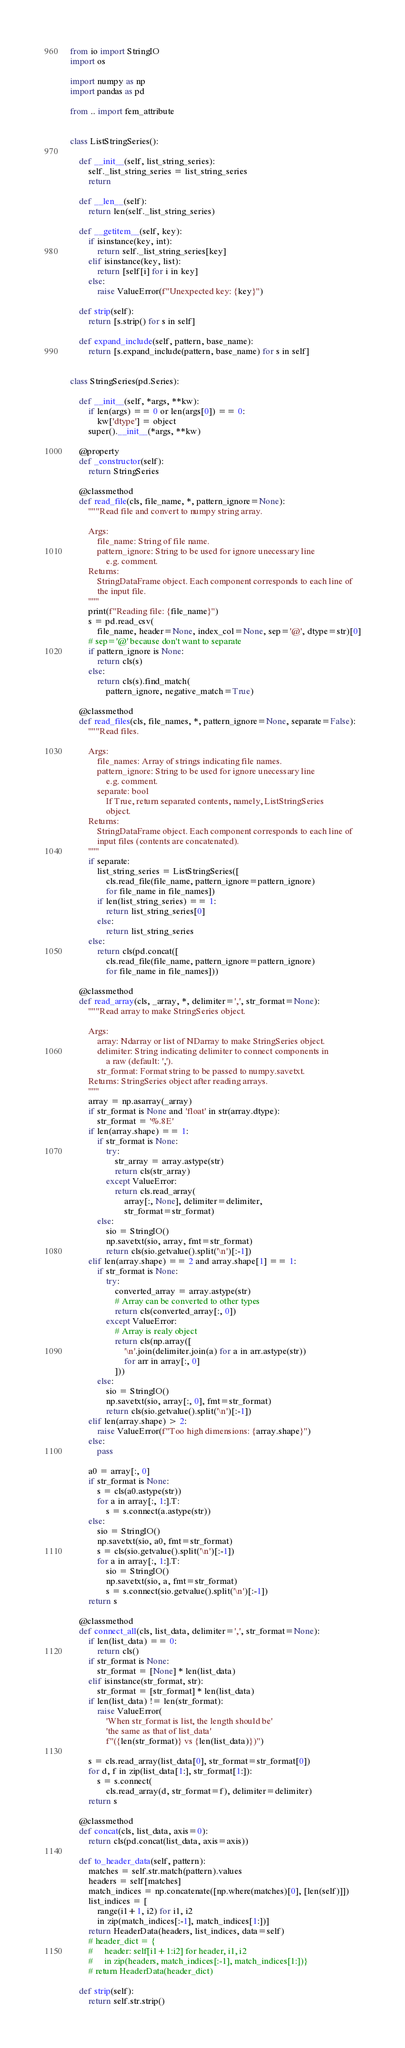<code> <loc_0><loc_0><loc_500><loc_500><_Python_>from io import StringIO
import os

import numpy as np
import pandas as pd

from .. import fem_attribute


class ListStringSeries():

    def __init__(self, list_string_series):
        self._list_string_series = list_string_series
        return

    def __len__(self):
        return len(self._list_string_series)

    def __getitem__(self, key):
        if isinstance(key, int):
            return self._list_string_series[key]
        elif isinstance(key, list):
            return [self[i] for i in key]
        else:
            raise ValueError(f"Unexpected key: {key}")

    def strip(self):
        return [s.strip() for s in self]

    def expand_include(self, pattern, base_name):
        return [s.expand_include(pattern, base_name) for s in self]


class StringSeries(pd.Series):

    def __init__(self, *args, **kw):
        if len(args) == 0 or len(args[0]) == 0:
            kw['dtype'] = object
        super().__init__(*args, **kw)

    @property
    def _constructor(self):
        return StringSeries

    @classmethod
    def read_file(cls, file_name, *, pattern_ignore=None):
        """Read file and convert to numpy string array.

        Args:
            file_name: String of file name.
            pattern_ignore: String to be used for ignore unecessary line
                e.g. comment.
        Returns:
            StringDataFrame object. Each component corresponds to each line of
            the input file.
        """
        print(f"Reading file: {file_name}")
        s = pd.read_csv(
            file_name, header=None, index_col=None, sep='@', dtype=str)[0]
        # sep='@' because don't want to separate
        if pattern_ignore is None:
            return cls(s)
        else:
            return cls(s).find_match(
                pattern_ignore, negative_match=True)

    @classmethod
    def read_files(cls, file_names, *, pattern_ignore=None, separate=False):
        """Read files.

        Args:
            file_names: Array of strings indicating file names.
            pattern_ignore: String to be used for ignore unecessary line
                e.g. comment.
            separate: bool
                If True, return separated contents, namely, ListStringSeries
                object.
        Returns:
            StringDataFrame object. Each component corresponds to each line of
            input files (contents are concatenated).
        """
        if separate:
            list_string_series = ListStringSeries([
                cls.read_file(file_name, pattern_ignore=pattern_ignore)
                for file_name in file_names])
            if len(list_string_series) == 1:
                return list_string_series[0]
            else:
                return list_string_series
        else:
            return cls(pd.concat([
                cls.read_file(file_name, pattern_ignore=pattern_ignore)
                for file_name in file_names]))

    @classmethod
    def read_array(cls, _array, *, delimiter=',', str_format=None):
        """Read array to make StringSeries object.

        Args:
            array: Ndarray or list of NDarray to make StringSeries object.
            delimiter: String indicating delimiter to connect components in
                a raw (default: ',').
            str_format: Format string to be passed to numpy.savetxt.
        Returns: StringSeries object after reading arrays.
        """
        array = np.asarray(_array)
        if str_format is None and 'float' in str(array.dtype):
            str_format = '%.8E'
        if len(array.shape) == 1:
            if str_format is None:
                try:
                    str_array = array.astype(str)
                    return cls(str_array)
                except ValueError:
                    return cls.read_array(
                        array[:, None], delimiter=delimiter,
                        str_format=str_format)
            else:
                sio = StringIO()
                np.savetxt(sio, array, fmt=str_format)
                return cls(sio.getvalue().split('\n')[:-1])
        elif len(array.shape) == 2 and array.shape[1] == 1:
            if str_format is None:
                try:
                    converted_array = array.astype(str)
                    # Array can be converted to other types
                    return cls(converted_array[:, 0])
                except ValueError:
                    # Array is realy object
                    return cls(np.array([
                        '\n'.join(delimiter.join(a) for a in arr.astype(str))
                        for arr in array[:, 0]
                    ]))
            else:
                sio = StringIO()
                np.savetxt(sio, array[:, 0], fmt=str_format)
                return cls(sio.getvalue().split('\n')[:-1])
        elif len(array.shape) > 2:
            raise ValueError(f"Too high dimensions: {array.shape}")
        else:
            pass

        a0 = array[:, 0]
        if str_format is None:
            s = cls(a0.astype(str))
            for a in array[:, 1:].T:
                s = s.connect(a.astype(str))
        else:
            sio = StringIO()
            np.savetxt(sio, a0, fmt=str_format)
            s = cls(sio.getvalue().split('\n')[:-1])
            for a in array[:, 1:].T:
                sio = StringIO()
                np.savetxt(sio, a, fmt=str_format)
                s = s.connect(sio.getvalue().split('\n')[:-1])
        return s

    @classmethod
    def connect_all(cls, list_data, delimiter=',', str_format=None):
        if len(list_data) == 0:
            return cls()
        if str_format is None:
            str_format = [None] * len(list_data)
        elif isinstance(str_format, str):
            str_format = [str_format] * len(list_data)
        if len(list_data) != len(str_format):
            raise ValueError(
                'When str_format is list, the length should be'
                'the same as that of list_data'
                f"({len(str_format)} vs {len(list_data)})")

        s = cls.read_array(list_data[0], str_format=str_format[0])
        for d, f in zip(list_data[1:], str_format[1:]):
            s = s.connect(
                cls.read_array(d, str_format=f), delimiter=delimiter)
        return s

    @classmethod
    def concat(cls, list_data, axis=0):
        return cls(pd.concat(list_data, axis=axis))

    def to_header_data(self, pattern):
        matches = self.str.match(pattern).values
        headers = self[matches]
        match_indices = np.concatenate([np.where(matches)[0], [len(self)]])
        list_indices = [
            range(i1+1, i2) for i1, i2
            in zip(match_indices[:-1], match_indices[1:])]
        return HeaderData(headers, list_indices, data=self)
        # header_dict = {
        #     header: self[i1+1:i2] for header, i1, i2
        #     in zip(headers, match_indices[:-1], match_indices[1:])}
        # return HeaderData(header_dict)

    def strip(self):
        return self.str.strip()
</code> 